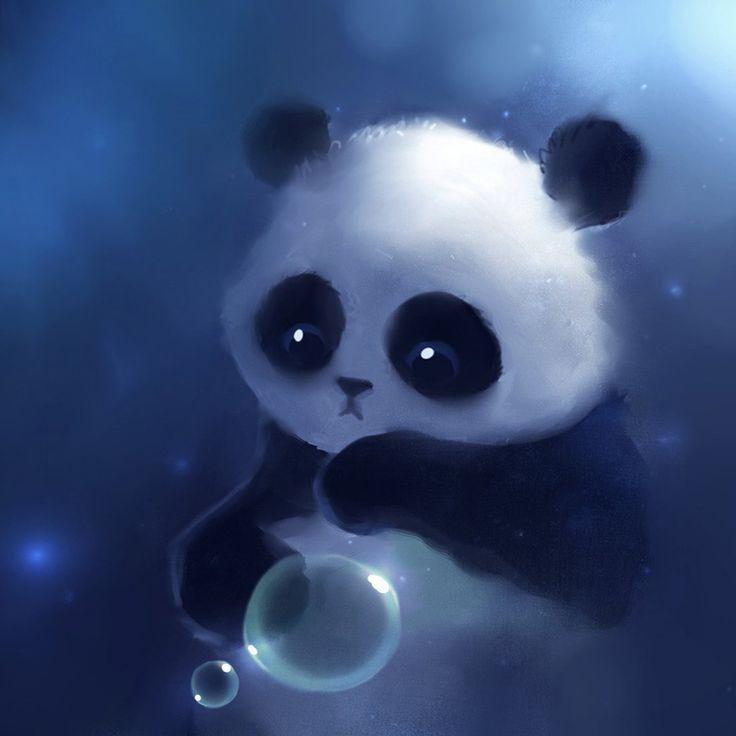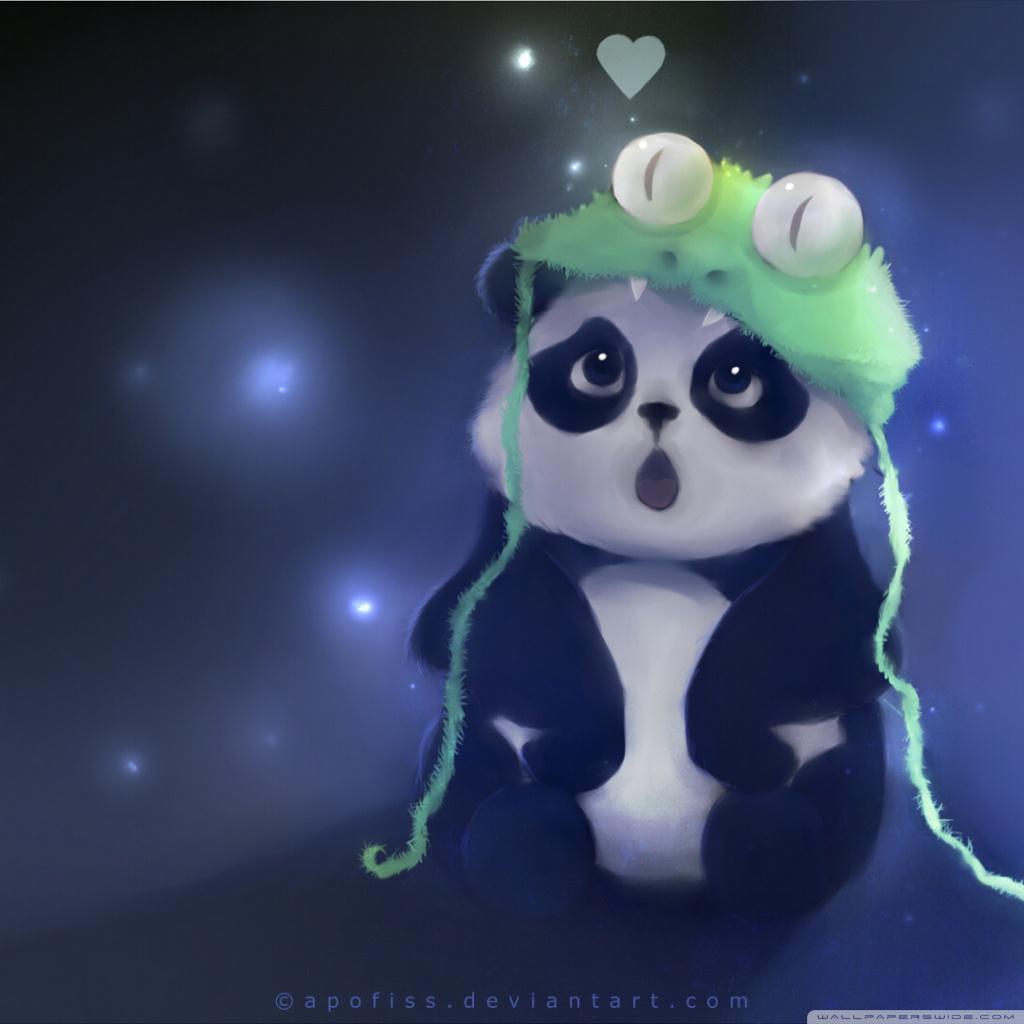The first image is the image on the left, the second image is the image on the right. Evaluate the accuracy of this statement regarding the images: "At least one panda is playing with a bubble.". Is it true? Answer yes or no. Yes. 